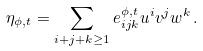Convert formula to latex. <formula><loc_0><loc_0><loc_500><loc_500>\eta _ { \phi , t } = \sum _ { i + j + k \geq 1 } e ^ { \phi , t } _ { i j k } u ^ { i } v ^ { j } w ^ { k } \, .</formula> 